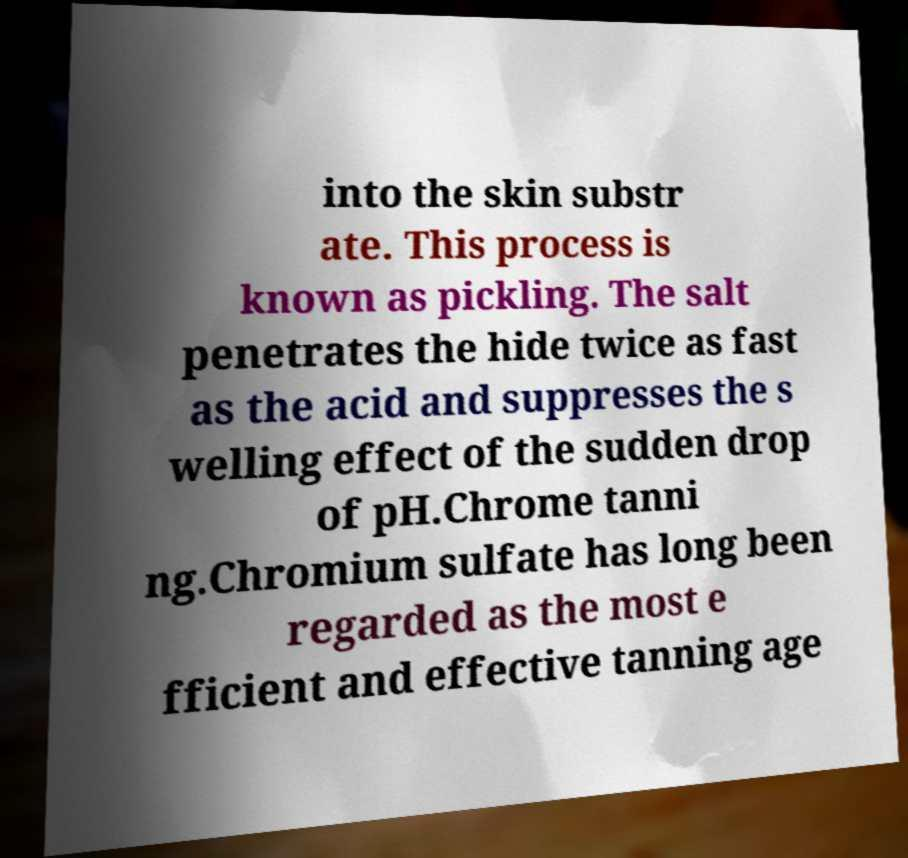Please identify and transcribe the text found in this image. into the skin substr ate. This process is known as pickling. The salt penetrates the hide twice as fast as the acid and suppresses the s welling effect of the sudden drop of pH.Chrome tanni ng.Chromium sulfate has long been regarded as the most e fficient and effective tanning age 